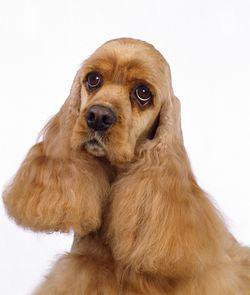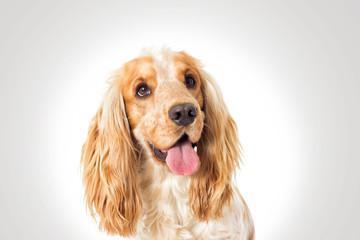The first image is the image on the left, the second image is the image on the right. For the images displayed, is the sentence "The tongue is out on one of the dog." factually correct? Answer yes or no. Yes. The first image is the image on the left, the second image is the image on the right. Examine the images to the left and right. Is the description "An image shows a spaniel looking upward to the right." accurate? Answer yes or no. Yes. 